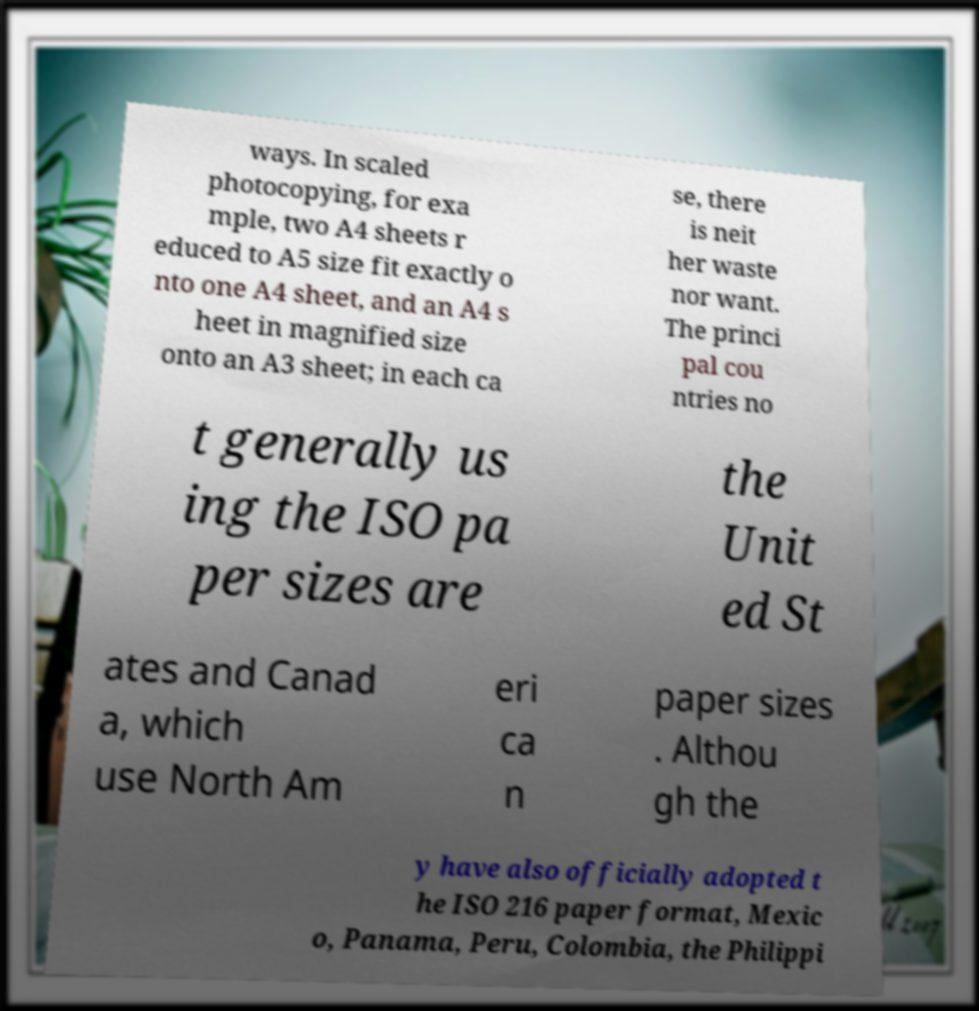What messages or text are displayed in this image? I need them in a readable, typed format. ways. In scaled photocopying, for exa mple, two A4 sheets r educed to A5 size fit exactly o nto one A4 sheet, and an A4 s heet in magnified size onto an A3 sheet; in each ca se, there is neit her waste nor want. The princi pal cou ntries no t generally us ing the ISO pa per sizes are the Unit ed St ates and Canad a, which use North Am eri ca n paper sizes . Althou gh the y have also officially adopted t he ISO 216 paper format, Mexic o, Panama, Peru, Colombia, the Philippi 